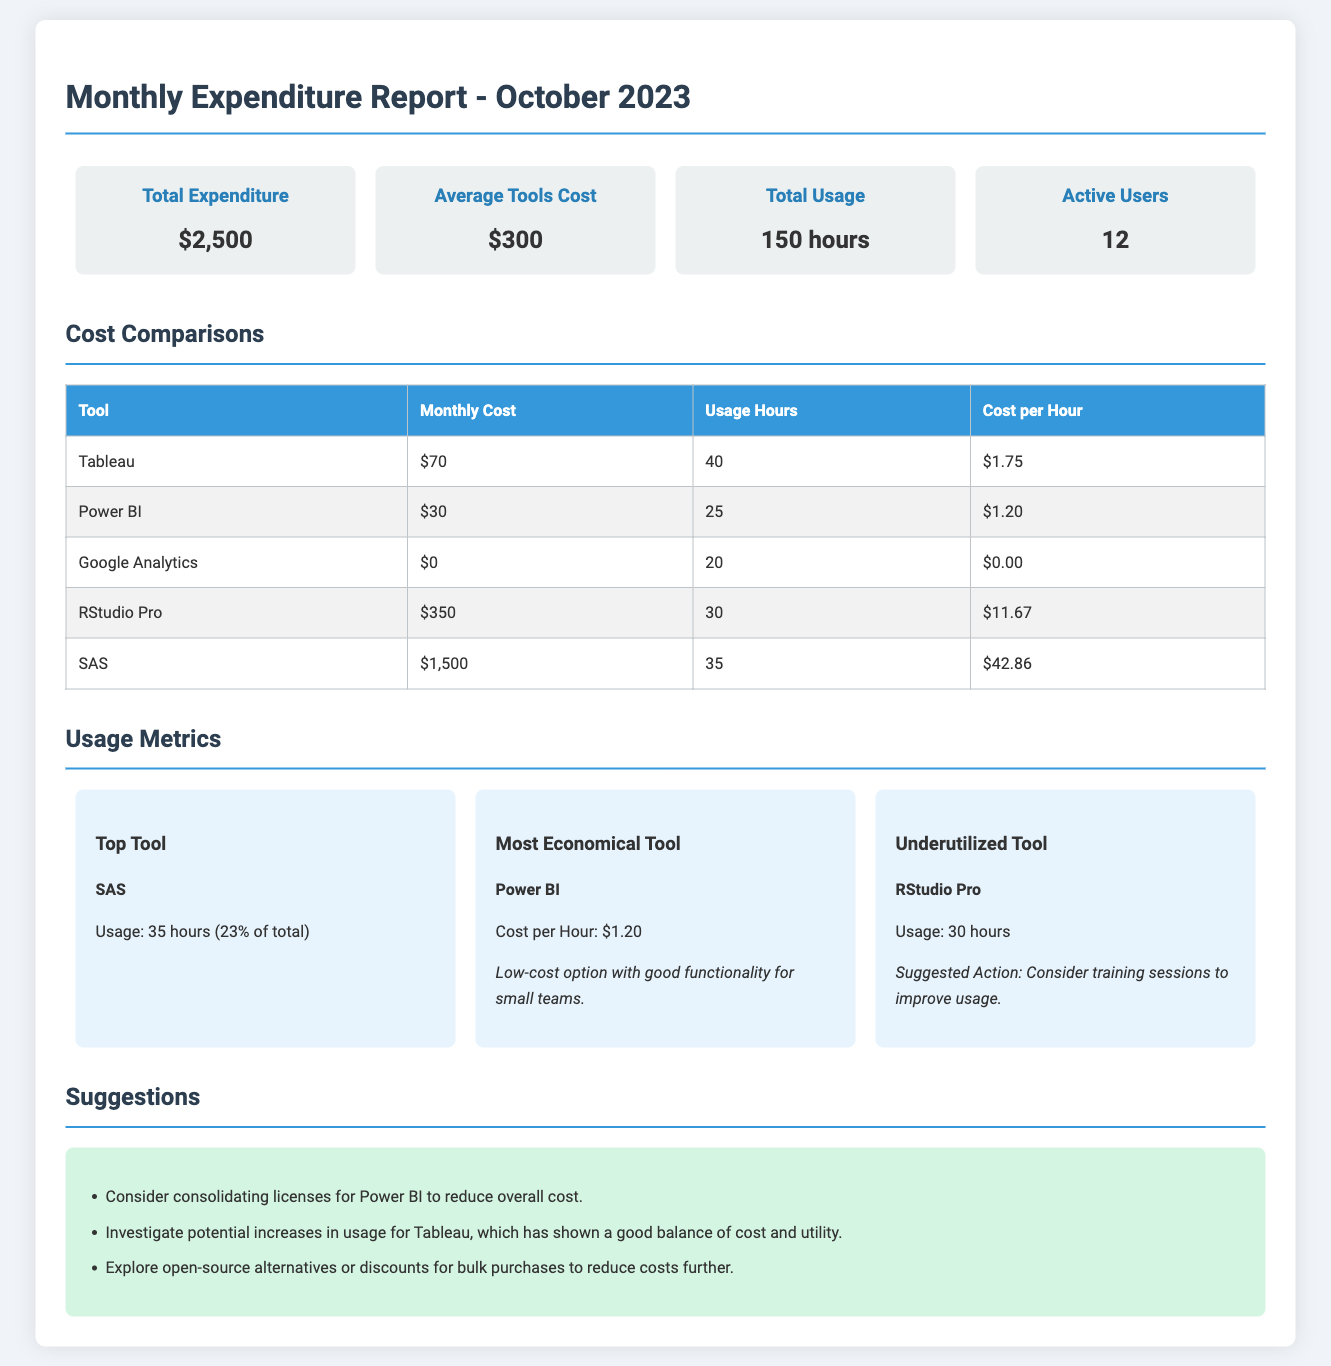What is the total expenditure for October 2023? The total expenditure reported for October 2023 is a straightforward figure presented in the overview section.
Answer: $2,500 What is the average cost of the tools? The average cost is provided in the overview section, calculated from the total spend on tools.
Answer: $300 How many total usage hours were recorded? Total usage hours are indicated in the overview section, providing insight into how much the tools were used.
Answer: 150 hours Which tool had the highest monthly cost? The monthly cost table lists each tool, allowing for quick identification of the highest cost.
Answer: SAS What is the cost per hour for Power BI? The cost per hour is derived from the monthly cost and usage hours for Power BI shown in the cost comparison table.
Answer: $1.20 What percentage of total usage hours was attributed to SAS? SAS usage is noted in the usage metrics section, allowing for a percentage calculation based on the total hours.
Answer: 23% Which tool is identified as the most economical? The overview section offers a clear identification of the tool deemed most economical based on cost per hour.
Answer: Power BI What is the suggested action for underutilized tools? A specific suggestion regarding training is mentioned for an underutilized tool in the usage metrics section.
Answer: Consider training sessions to improve usage What is one suggestion for cost reduction mentioned in the document? The suggestions section lists various strategies to reduce costs associated with the tools.
Answer: Consider consolidating licenses for Power BI to reduce overall cost 